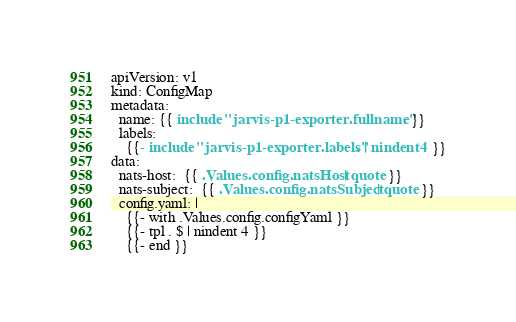<code> <loc_0><loc_0><loc_500><loc_500><_YAML_>apiVersion: v1
kind: ConfigMap
metadata:
  name: {{ include "jarvis-p1-exporter.fullname" . }}
  labels:
    {{- include "jarvis-p1-exporter.labels" . | nindent 4 }}
data:
  nats-host:  {{ .Values.config.natsHost | quote }}
  nats-subject:  {{ .Values.config.natsSubject | quote }}
  config.yaml: |
    {{- with .Values.config.configYaml }}
    {{- tpl . $ | nindent 4 }}
    {{- end }}</code> 